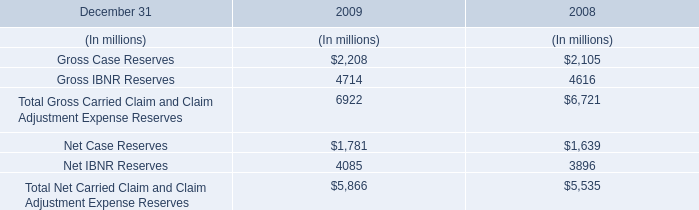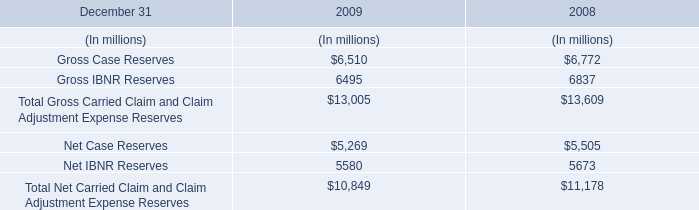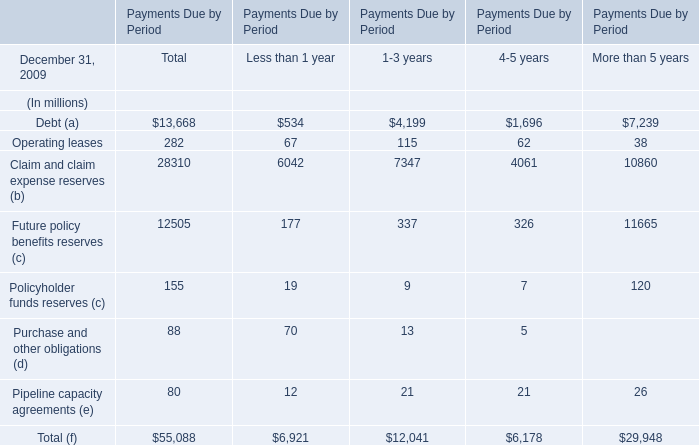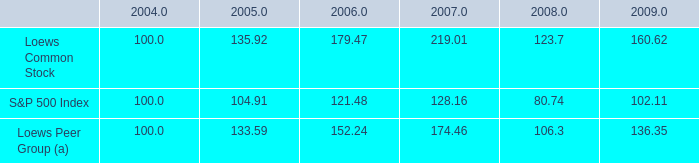What was the sum of Operating leases without those Less than 1 year smaller than 70 in 2009? (in million) 
Computations: ((115 + 62) + 38)
Answer: 215.0. 